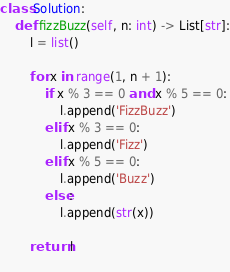<code> <loc_0><loc_0><loc_500><loc_500><_Python_>class Solution:
    def fizzBuzz(self, n: int) -> List[str]:
        l = list()
        
        for x in range(1, n + 1):
            if x % 3 == 0 and x % 5 == 0:
                l.append('FizzBuzz')
            elif x % 3 == 0:
                l.append('Fizz')
            elif x % 5 == 0:
                l.append('Buzz')
            else:
                l.append(str(x))
                
        return l
            </code> 